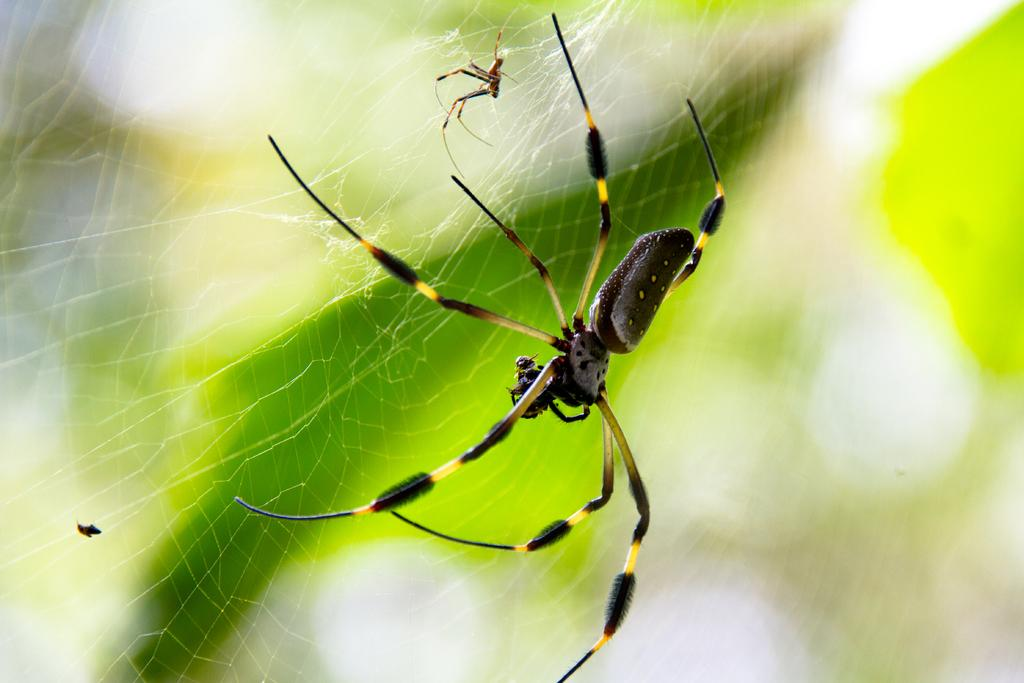What is the main subject in the middle of the image? There is a spider in the middle of the image. Can you describe the appearance of the spider? The spider has a black and yellow color combination. Where is the spider located? The spider is on a web. Are there any other spiders in the image? Yes, there is another spider on the web. How would you describe the background of the image? The background of the image is blurred. What type of building can be seen in the background of the image? There is no building visible in the background of the image; the background is blurred. How does the mist affect the visibility of the kite in the image? There is no kite present in the image, so its visibility is not affected by any mist. 